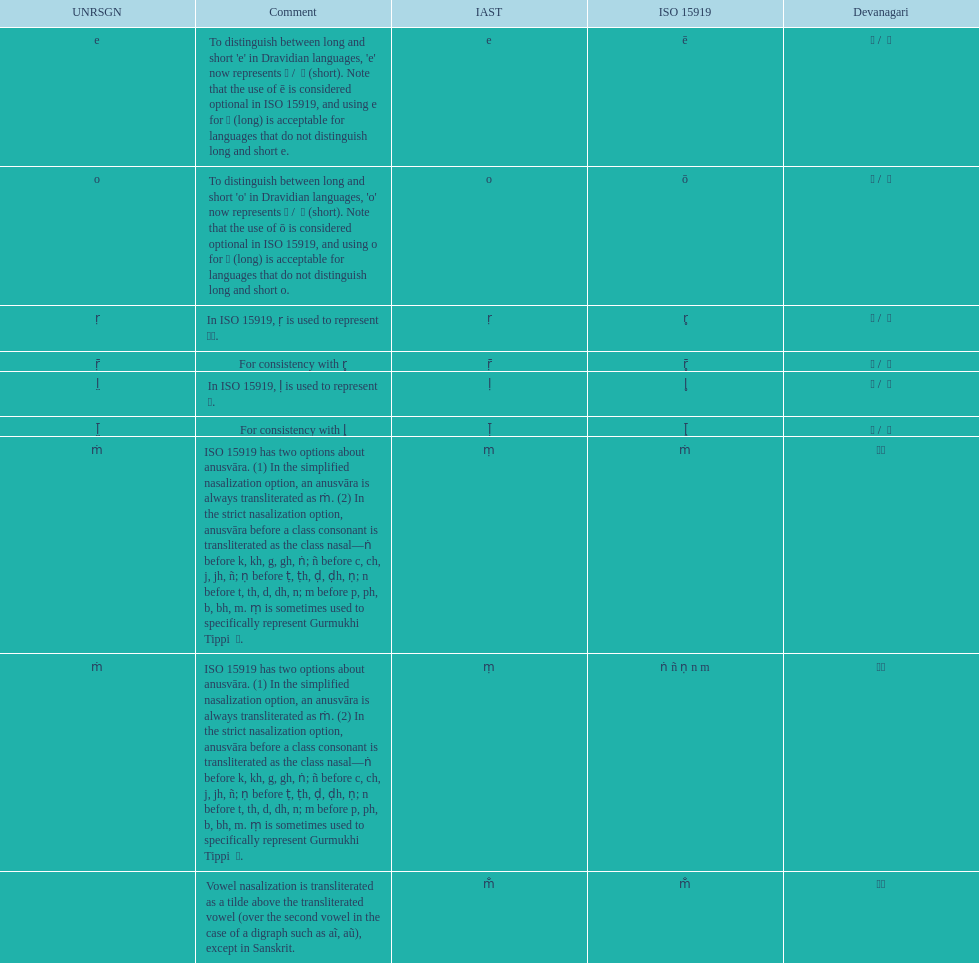Could you parse the entire table as a dict? {'header': ['UNRSGN', 'Comment', 'IAST', 'ISO 15919', 'Devanagari'], 'rows': [['e', "To distinguish between long and short 'e' in Dravidian languages, 'e' now represents ऎ / \xa0ॆ (short). Note that the use of ē is considered optional in ISO 15919, and using e for ए (long) is acceptable for languages that do not distinguish long and short e.", 'e', 'ē', 'ए / \xa0े'], ['o', "To distinguish between long and short 'o' in Dravidian languages, 'o' now represents ऒ / \xa0ॊ (short). Note that the use of ō is considered optional in ISO 15919, and using o for ओ (long) is acceptable for languages that do not distinguish long and short o.", 'o', 'ō', 'ओ / \xa0ो'], ['ṛ', 'In ISO 15919, ṛ is used to represent ड़.', 'ṛ', 'r̥', 'ऋ / \xa0ृ'], ['ṝ', 'For consistency with r̥', 'ṝ', 'r̥̄', 'ॠ / \xa0ॄ'], ['l̤', 'In ISO 15919, ḷ is used to represent ळ.', 'ḷ', 'l̥', 'ऌ / \xa0ॢ'], ['l̤̄', 'For consistency with l̥', 'ḹ', 'l̥̄', 'ॡ / \xa0ॣ'], ['ṁ', 'ISO 15919 has two options about anusvāra. (1) In the simplified nasalization option, an anusvāra is always transliterated as ṁ. (2) In the strict nasalization option, anusvāra before a class consonant is transliterated as the class nasal—ṅ before k, kh, g, gh, ṅ; ñ before c, ch, j, jh, ñ; ṇ before ṭ, ṭh, ḍ, ḍh, ṇ; n before t, th, d, dh, n; m before p, ph, b, bh, m. ṃ is sometimes used to specifically represent Gurmukhi Tippi \xa0ੰ.', 'ṃ', 'ṁ', '◌ं'], ['ṁ', 'ISO 15919 has two options about anusvāra. (1) In the simplified nasalization option, an anusvāra is always transliterated as ṁ. (2) In the strict nasalization option, anusvāra before a class consonant is transliterated as the class nasal—ṅ before k, kh, g, gh, ṅ; ñ before c, ch, j, jh, ñ; ṇ before ṭ, ṭh, ḍ, ḍh, ṇ; n before t, th, d, dh, n; m before p, ph, b, bh, m. ṃ is sometimes used to specifically represent Gurmukhi Tippi \xa0ੰ.', 'ṃ', 'ṅ ñ ṇ n m', '◌ं'], ['', 'Vowel nasalization is transliterated as a tilde above the transliterated vowel (over the second vowel in the case of a digraph such as aĩ, aũ), except in Sanskrit.', 'm̐', 'm̐', '◌ँ']]} Which devanagari transliteration is listed on the top of the table? ए / े. 